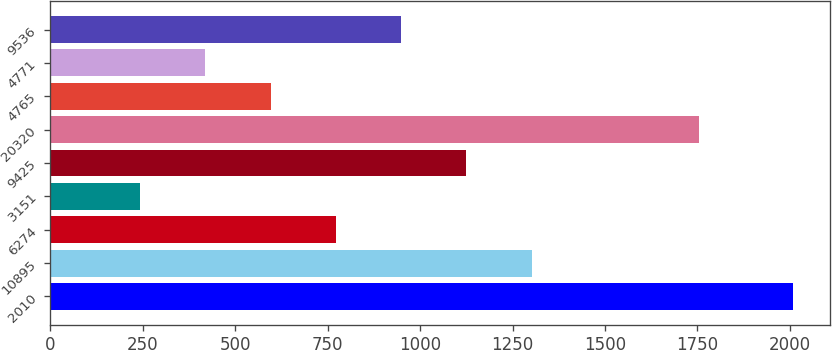Convert chart. <chart><loc_0><loc_0><loc_500><loc_500><bar_chart><fcel>2010<fcel>10895<fcel>6274<fcel>3151<fcel>9425<fcel>20320<fcel>4765<fcel>4771<fcel>9536<nl><fcel>2008<fcel>1301.68<fcel>771.94<fcel>242.2<fcel>1125.1<fcel>1755.4<fcel>595.36<fcel>418.78<fcel>948.52<nl></chart> 